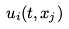Convert formula to latex. <formula><loc_0><loc_0><loc_500><loc_500>u _ { i } ( t , x _ { j } )</formula> 